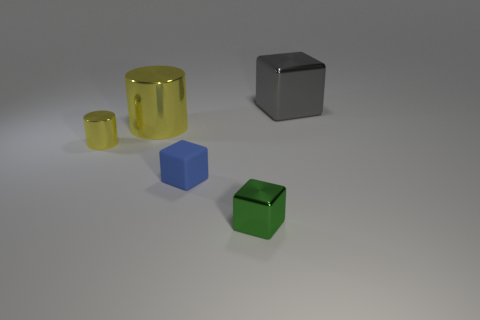What materials do these objects appear to be made of? The objects in the image look like they are made from different materials. The small and large yellow objects have a translucent appearance, suggesting a glass or plastic-like material. Meanwhile, the gray block has a matte finish, which could imply a metallic or stone composition, and the green and blue cubes seem to be made of a material with a dull sheen, possibly rubber or a matte plastic. 